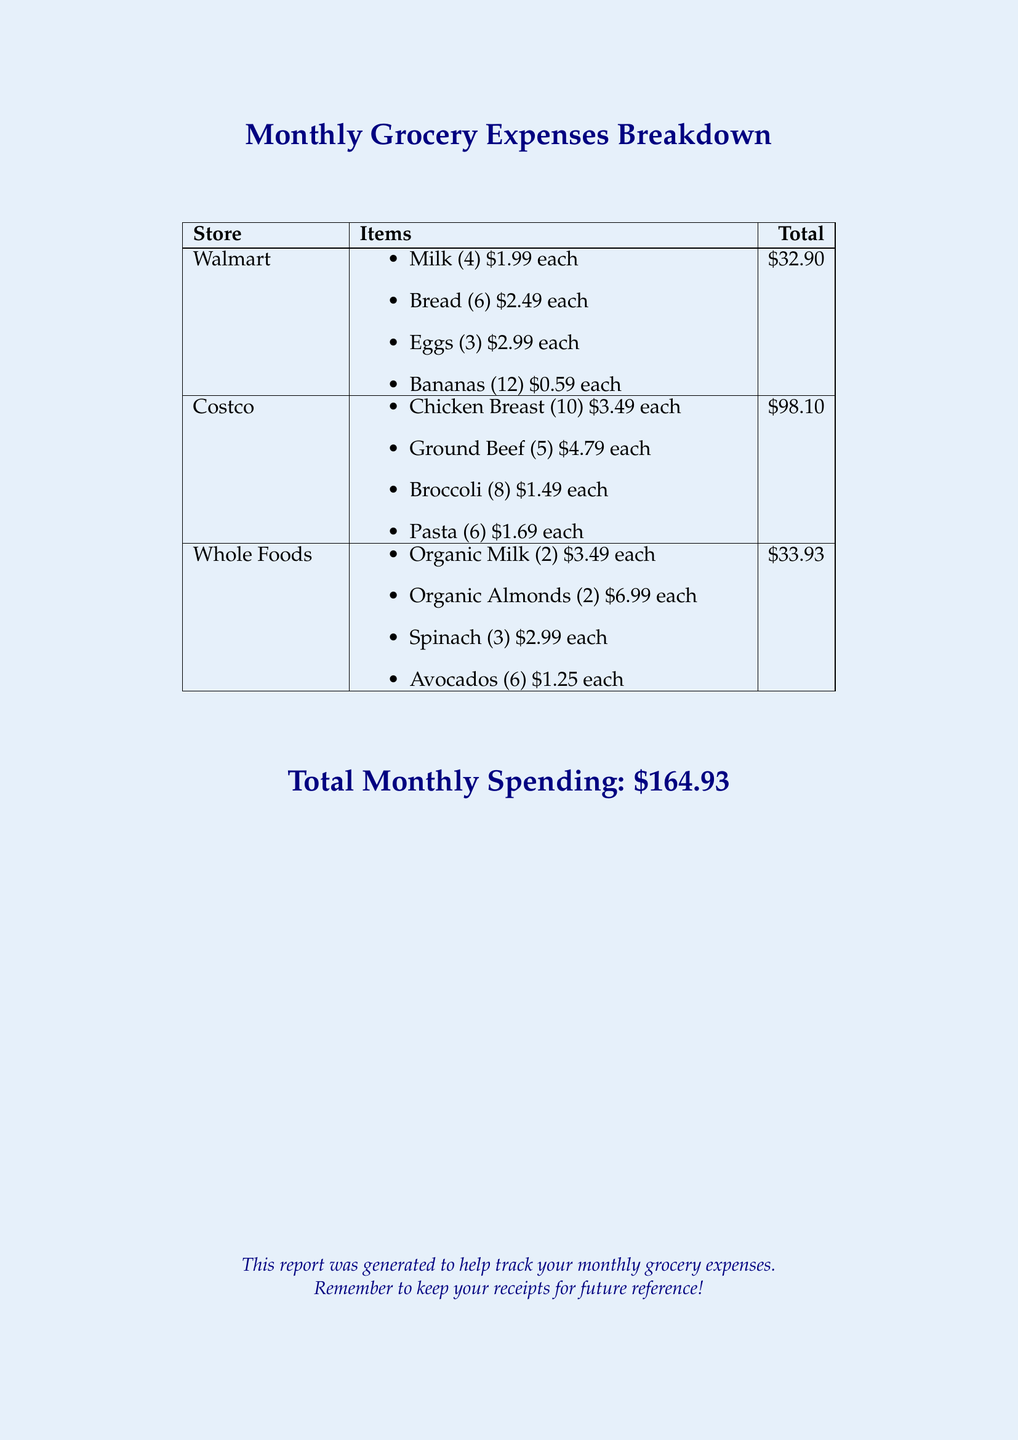What is the total spending at Walmart? Total spending at Walmart is listed in the table under "Total."
Answer: $32.90 How many items were bought from Costco? The items bought from Costco are listed individually in the table, totaling 29 items.
Answer: 29 What is the cost of a dozen bananas? The price per banana is listed, and with 12 bananas, it is calculated as 12 x $0.59.
Answer: $7.08 Which store had the highest total spending? The total spending for each store can be compared, with Costco showing the highest amount.
Answer: Costco What is the total monthly spending? The total monthly spending is provided at the bottom of the document.
Answer: $164.93 How many eggs were purchased? The number of eggs is listed in the itemized list under Walmart.
Answer: 3 What is the total cost of Organic Almonds? The cost per unit and quantity of Organic Almonds can be multiplied to find the total.
Answer: $13.98 How many stores are included in the report? The document includes a table with distinct entries for each store, providing a count.
Answer: 3 